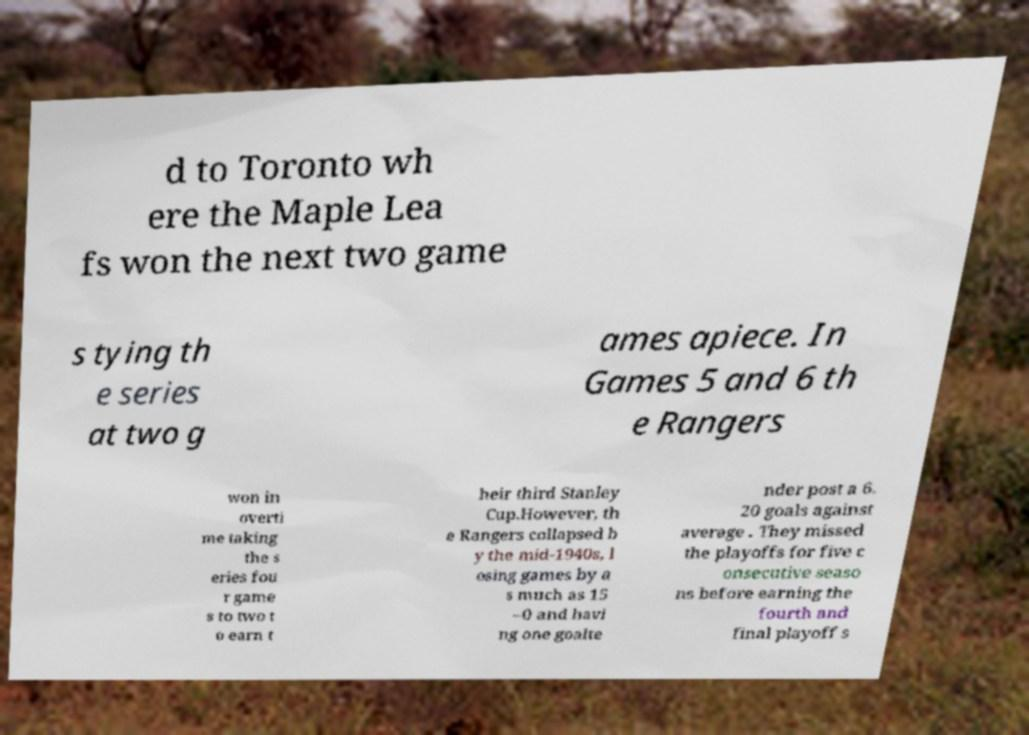What messages or text are displayed in this image? I need them in a readable, typed format. d to Toronto wh ere the Maple Lea fs won the next two game s tying th e series at two g ames apiece. In Games 5 and 6 th e Rangers won in overti me taking the s eries fou r game s to two t o earn t heir third Stanley Cup.However, th e Rangers collapsed b y the mid-1940s, l osing games by a s much as 15 –0 and havi ng one goalte nder post a 6. 20 goals against average . They missed the playoffs for five c onsecutive seaso ns before earning the fourth and final playoff s 